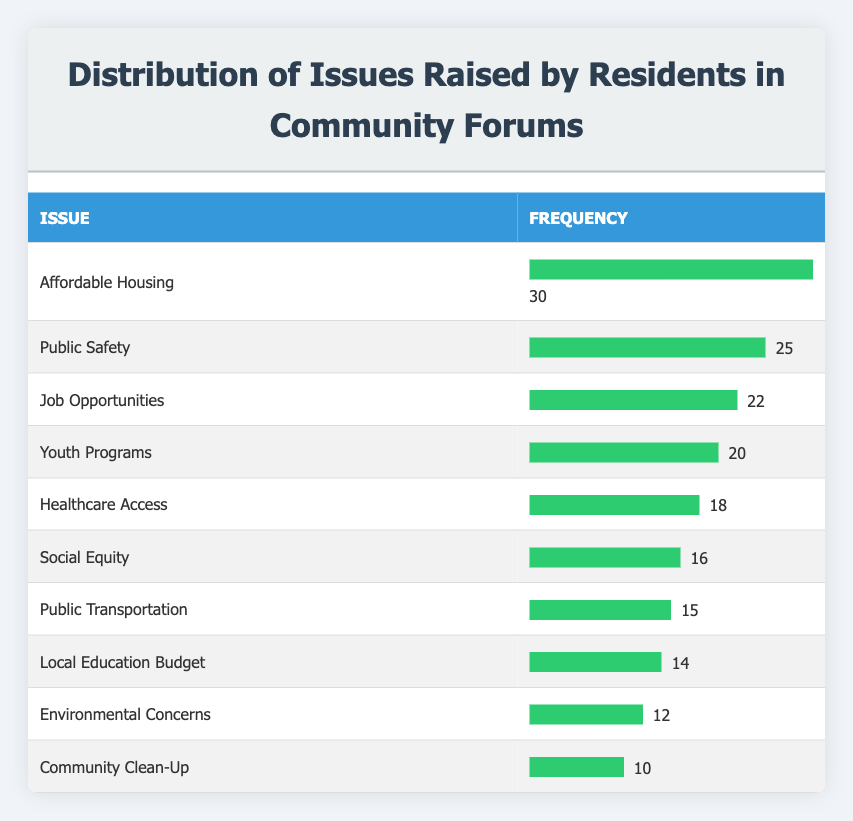What is the issue with the highest frequency reported by residents? Looking at the frequency for each issue, "Affordable Housing" has the highest frequency at 30.
Answer: Affordable Housing How many issues have a frequency greater than 15? The issues with a frequency greater than 15 are "Affordable Housing" (30), "Public Safety" (25), "Job Opportunities" (22), "Youth Programs" (20), "Healthcare Access" (18), and "Social Equity" (16). Counting these gives us 6 issues.
Answer: 6 Which issue has the lowest frequency? The issue with the lowest frequency is "Community Clean-Up" with a frequency of 10, as shown in the table.
Answer: Community Clean-Up What is the total frequency of all issues listed in the table? To find the total frequency, we add the frequencies: 30 + 25 + 22 + 20 + 18 + 16 + 15 + 14 + 12 + 10 =  250.
Answer: 250 Is "Public Transportation" one of the top three issues raised? The top three issues by frequency are "Affordable Housing" (30), "Public Safety" (25), and "Job Opportunities" (22), so "Public Transportation" (15) is not among them.
Answer: No What is the average frequency of the issues? To find the average frequency, we sum all frequencies (250) and divide by the number of issues (10): 250 / 10 = 25.
Answer: 25 Which two issues combined have the same frequency as "Healthcare Access"? "Social Equity" (16) and "Public Transportation" (15) combine to equal 31, but if we take "Public Safety" (25) and "Job Opportunities" (22), both are greater. Therefore, no two issues equal the frequency of "Healthcare Access" (18).
Answer: No What percentage of issues have frequencies less than 15? The issues with frequencies less than 15 are "Local Education Budget" (14), "Environmental Concerns" (12), and "Community Clean-Up" (10). That’s a total of 3 out of 10 issues, so the percentage is (3/10) * 100% = 30%.
Answer: 30% 